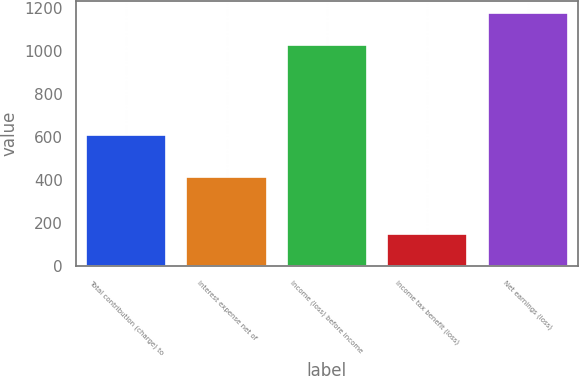<chart> <loc_0><loc_0><loc_500><loc_500><bar_chart><fcel>Total contribution (charge) to<fcel>Interest expense net of<fcel>Income (loss) before income<fcel>Income tax benefit (loss)<fcel>Net earnings (loss)<nl><fcel>611<fcel>415<fcel>1026<fcel>150<fcel>1176<nl></chart> 